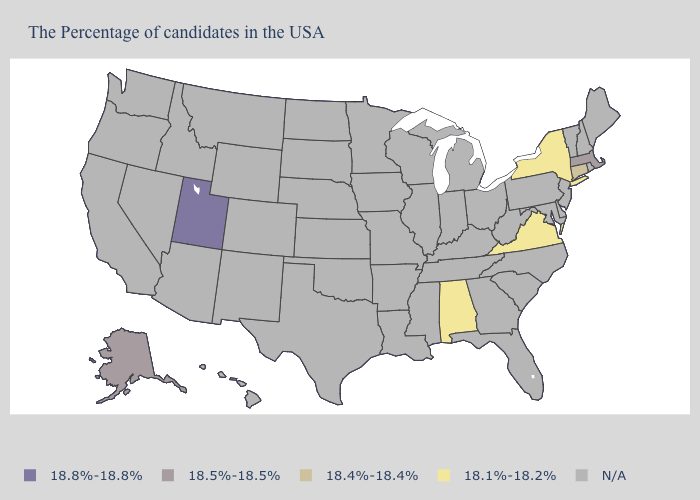Name the states that have a value in the range 18.4%-18.4%?
Be succinct. Connecticut. What is the value of Alabama?
Concise answer only. 18.1%-18.2%. Which states have the lowest value in the USA?
Quick response, please. New York, Virginia, Alabama. What is the value of Maine?
Give a very brief answer. N/A. What is the value of Missouri?
Keep it brief. N/A. What is the lowest value in states that border West Virginia?
Concise answer only. 18.1%-18.2%. Among the states that border West Virginia , which have the highest value?
Keep it brief. Virginia. Name the states that have a value in the range 18.1%-18.2%?
Write a very short answer. New York, Virginia, Alabama. Which states hav the highest value in the West?
Give a very brief answer. Utah. Name the states that have a value in the range 18.1%-18.2%?
Concise answer only. New York, Virginia, Alabama. 